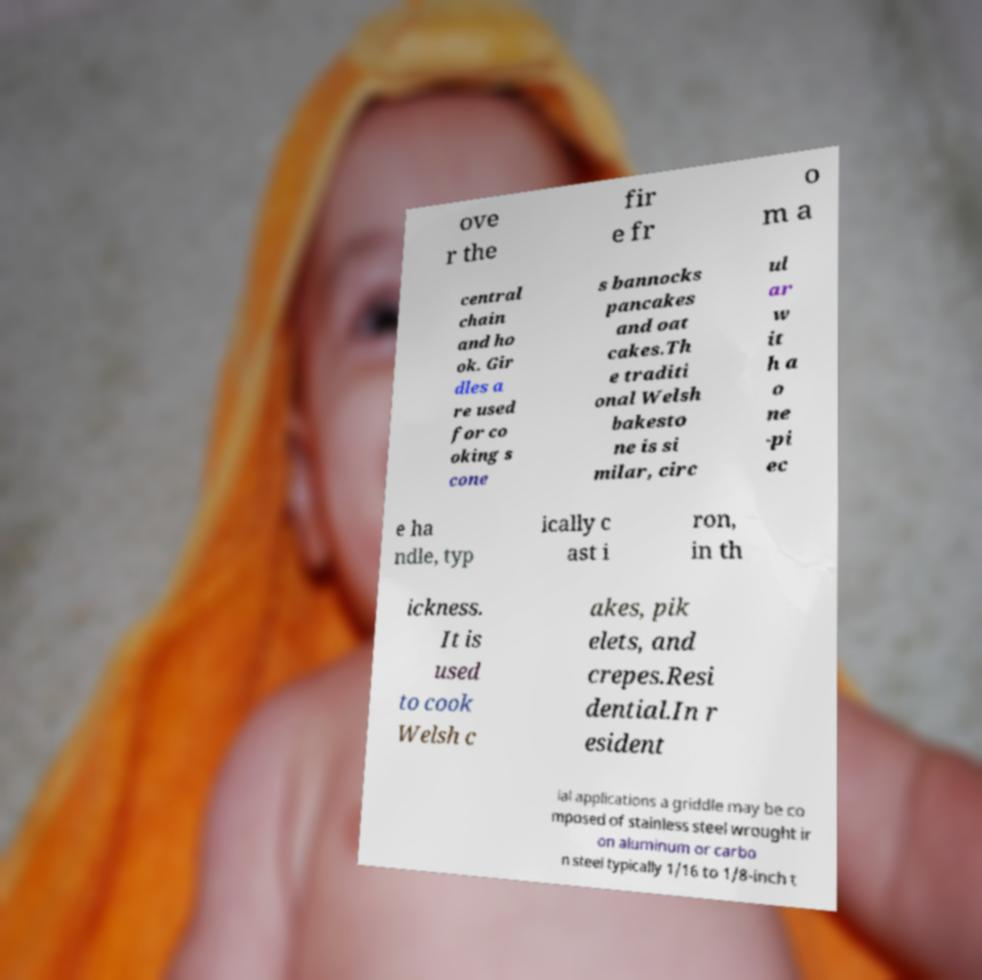I need the written content from this picture converted into text. Can you do that? ove r the fir e fr o m a central chain and ho ok. Gir dles a re used for co oking s cone s bannocks pancakes and oat cakes.Th e traditi onal Welsh bakesto ne is si milar, circ ul ar w it h a o ne -pi ec e ha ndle, typ ically c ast i ron, in th ickness. It is used to cook Welsh c akes, pik elets, and crepes.Resi dential.In r esident ial applications a griddle may be co mposed of stainless steel wrought ir on aluminum or carbo n steel typically 1/16 to 1/8-inch t 